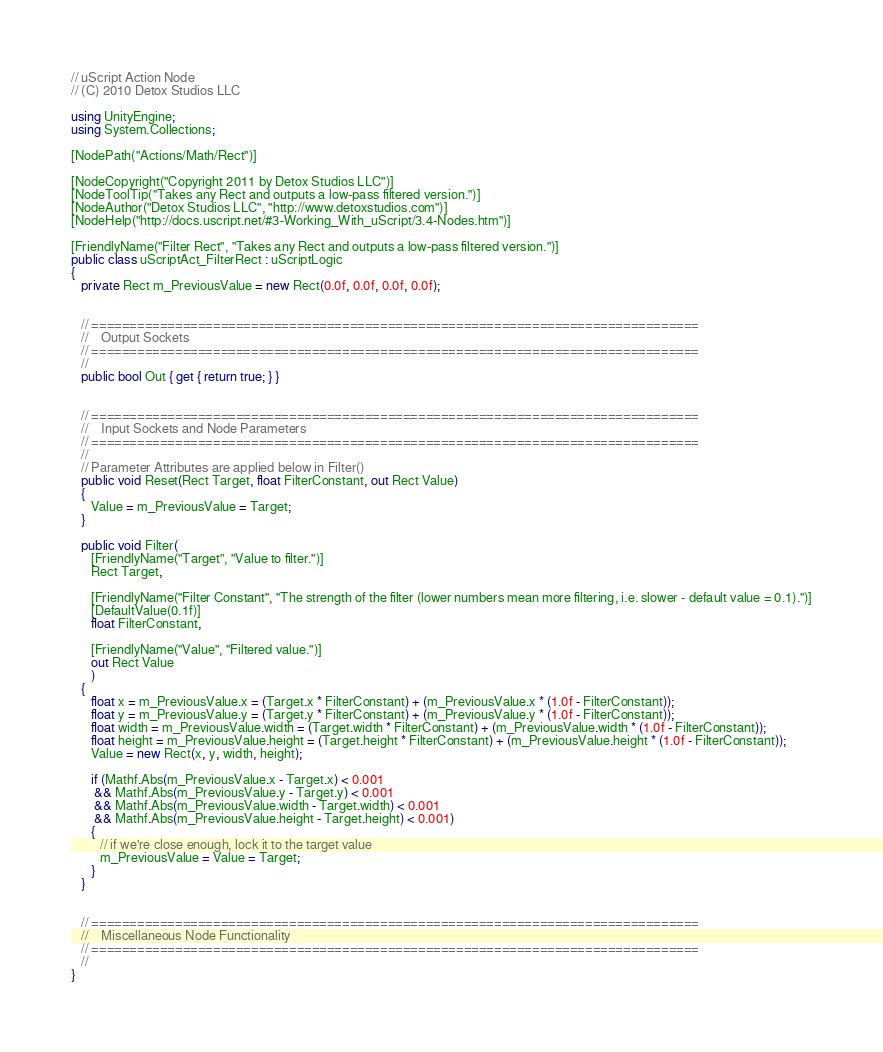Convert code to text. <code><loc_0><loc_0><loc_500><loc_500><_C#_>// uScript Action Node
// (C) 2010 Detox Studios LLC

using UnityEngine;
using System.Collections;

[NodePath("Actions/Math/Rect")]

[NodeCopyright("Copyright 2011 by Detox Studios LLC")]
[NodeToolTip("Takes any Rect and outputs a low-pass filtered version.")]
[NodeAuthor("Detox Studios LLC", "http://www.detoxstudios.com")]
[NodeHelp("http://docs.uscript.net/#3-Working_With_uScript/3.4-Nodes.htm")]

[FriendlyName("Filter Rect", "Takes any Rect and outputs a low-pass filtered version.")]
public class uScriptAct_FilterRect : uScriptLogic
{
   private Rect m_PreviousValue = new Rect(0.0f, 0.0f, 0.0f, 0.0f);


   // ================================================================================
   //    Output Sockets
   // ================================================================================
   //
   public bool Out { get { return true; } }


   // ================================================================================
   //    Input Sockets and Node Parameters
   // ================================================================================
   //
   // Parameter Attributes are applied below in Filter()
   public void Reset(Rect Target, float FilterConstant, out Rect Value)
   {
      Value = m_PreviousValue = Target;
   }

   public void Filter(
      [FriendlyName("Target", "Value to filter.")]
      Rect Target,

      [FriendlyName("Filter Constant", "The strength of the filter (lower numbers mean more filtering, i.e. slower - default value = 0.1).")]
      [DefaultValue(0.1f)]
      float FilterConstant,

      [FriendlyName("Value", "Filtered value.")]
      out Rect Value
      )
   {
      float x = m_PreviousValue.x = (Target.x * FilterConstant) + (m_PreviousValue.x * (1.0f - FilterConstant));
      float y = m_PreviousValue.y = (Target.y * FilterConstant) + (m_PreviousValue.y * (1.0f - FilterConstant));
      float width = m_PreviousValue.width = (Target.width * FilterConstant) + (m_PreviousValue.width * (1.0f - FilterConstant));
      float height = m_PreviousValue.height = (Target.height * FilterConstant) + (m_PreviousValue.height * (1.0f - FilterConstant));
      Value = new Rect(x, y, width, height);
      
      if (Mathf.Abs(m_PreviousValue.x - Target.x) < 0.001
       && Mathf.Abs(m_PreviousValue.y - Target.y) < 0.001
       && Mathf.Abs(m_PreviousValue.width - Target.width) < 0.001 
       && Mathf.Abs(m_PreviousValue.height - Target.height) < 0.001)
      {
         // if we're close enough, lock it to the target value
         m_PreviousValue = Value = Target;
      }
   }


   // ================================================================================
   //    Miscellaneous Node Functionality
   // ================================================================================
   //
}</code> 